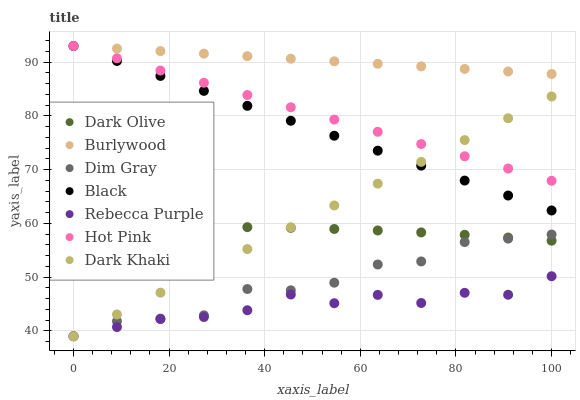Does Rebecca Purple have the minimum area under the curve?
Answer yes or no. Yes. Does Burlywood have the maximum area under the curve?
Answer yes or no. Yes. Does Dark Olive have the minimum area under the curve?
Answer yes or no. No. Does Dark Olive have the maximum area under the curve?
Answer yes or no. No. Is Dark Khaki the smoothest?
Answer yes or no. Yes. Is Dim Gray the roughest?
Answer yes or no. Yes. Is Burlywood the smoothest?
Answer yes or no. No. Is Burlywood the roughest?
Answer yes or no. No. Does Dim Gray have the lowest value?
Answer yes or no. Yes. Does Dark Olive have the lowest value?
Answer yes or no. No. Does Hot Pink have the highest value?
Answer yes or no. Yes. Does Dark Olive have the highest value?
Answer yes or no. No. Is Dark Olive less than Black?
Answer yes or no. Yes. Is Black greater than Dark Olive?
Answer yes or no. Yes. Does Black intersect Dark Khaki?
Answer yes or no. Yes. Is Black less than Dark Khaki?
Answer yes or no. No. Is Black greater than Dark Khaki?
Answer yes or no. No. Does Dark Olive intersect Black?
Answer yes or no. No. 